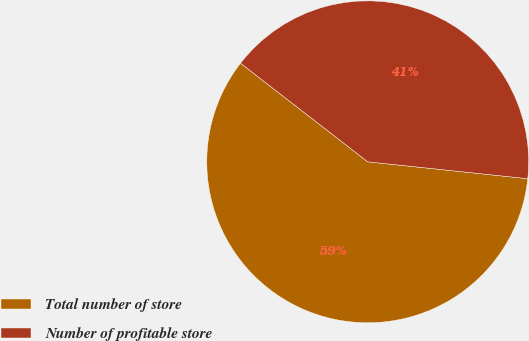<chart> <loc_0><loc_0><loc_500><loc_500><pie_chart><fcel>Total number of store<fcel>Number of profitable store<nl><fcel>58.82%<fcel>41.18%<nl></chart> 